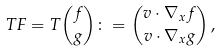<formula> <loc_0><loc_0><loc_500><loc_500>T F = T \binom { f } { g } \colon = \binom { v \cdot \nabla _ { x } f } { v \cdot \nabla _ { x } g } \, ,</formula> 